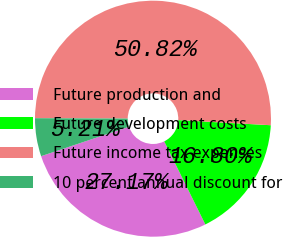Convert chart. <chart><loc_0><loc_0><loc_500><loc_500><pie_chart><fcel>Future production and<fcel>Future development costs<fcel>Future income tax expenses<fcel>10 percent annual discount for<nl><fcel>27.17%<fcel>16.8%<fcel>50.81%<fcel>5.21%<nl></chart> 